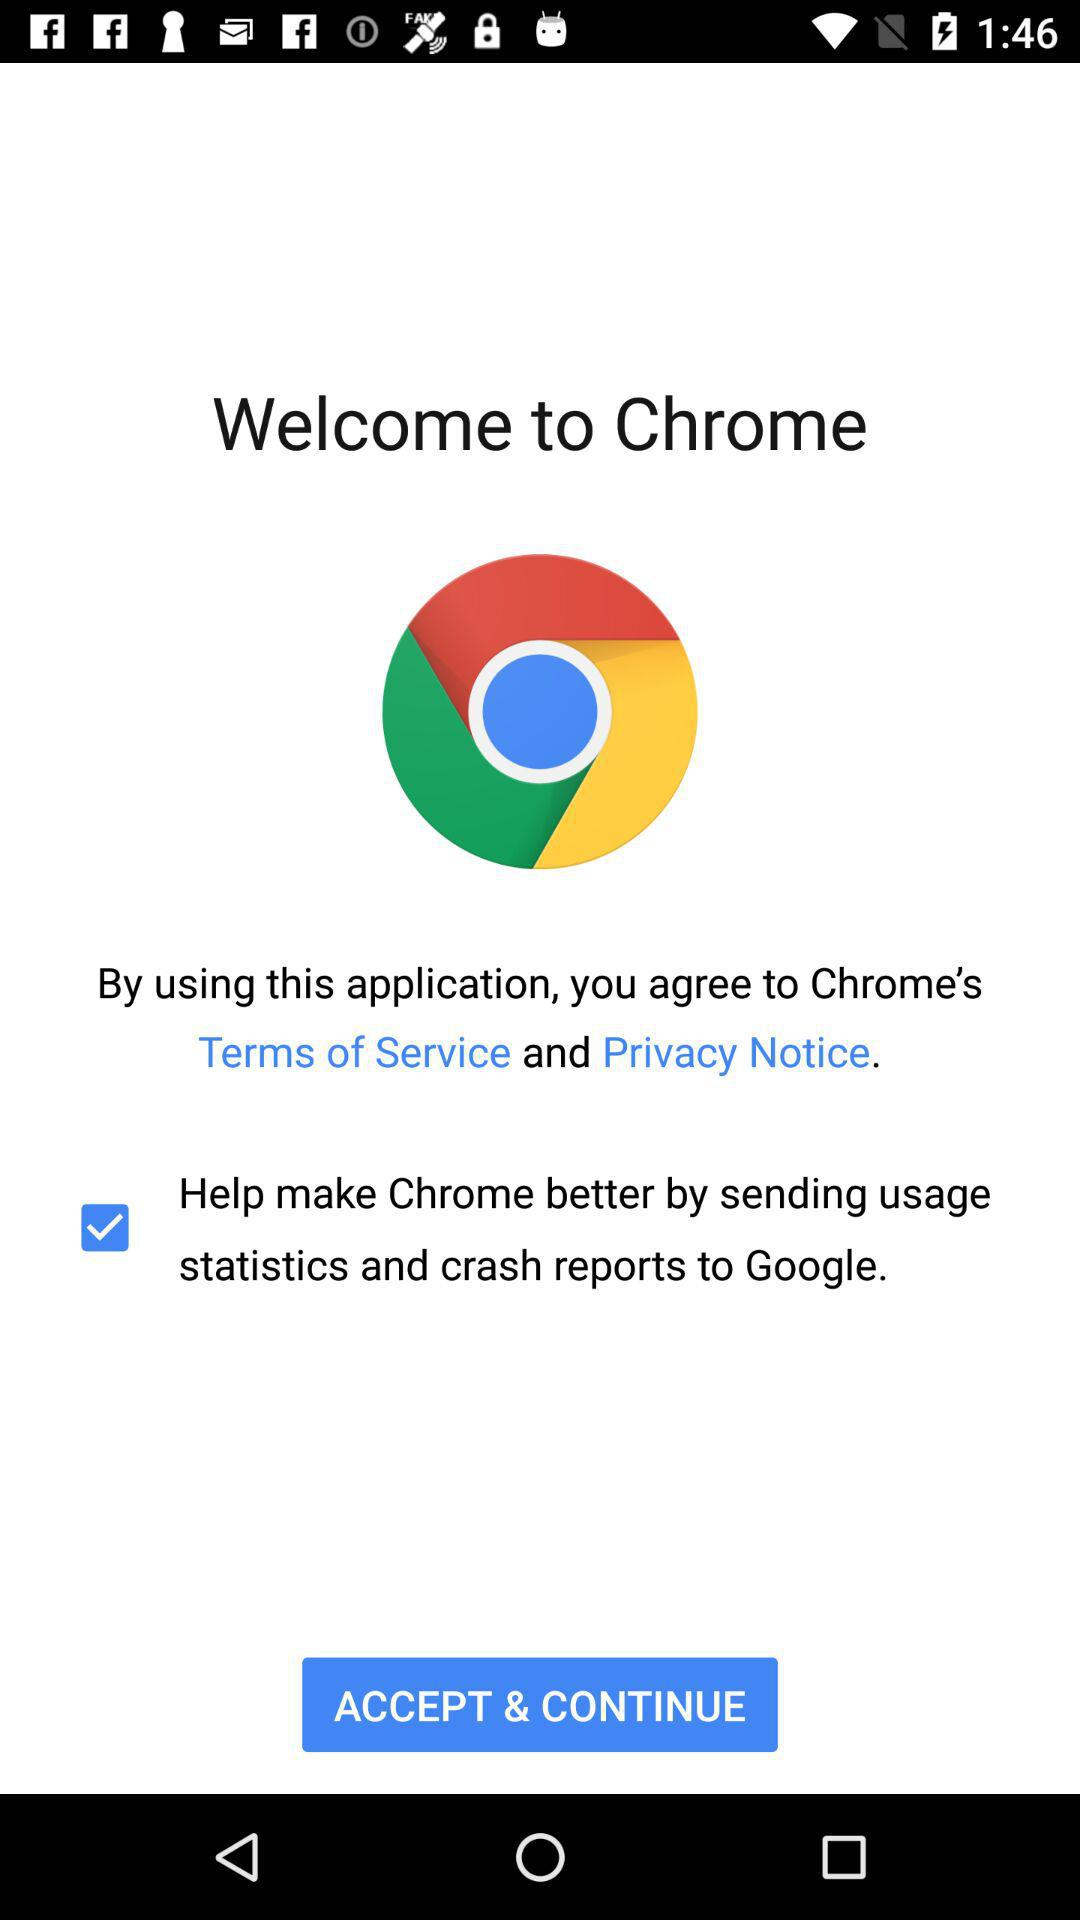What is the status of "Help make Chrome better by sending usage statistics and crash reports to Google."? The status is "on". 